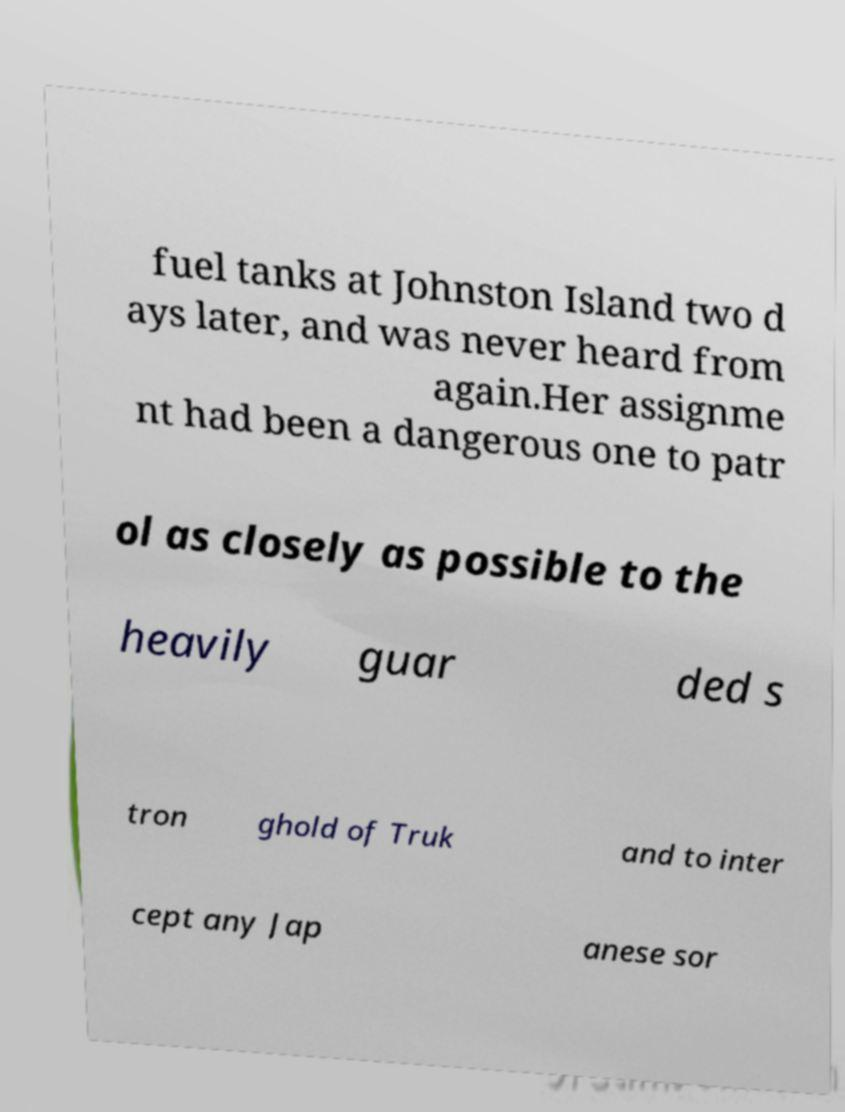Could you assist in decoding the text presented in this image and type it out clearly? fuel tanks at Johnston Island two d ays later, and was never heard from again.Her assignme nt had been a dangerous one to patr ol as closely as possible to the heavily guar ded s tron ghold of Truk and to inter cept any Jap anese sor 